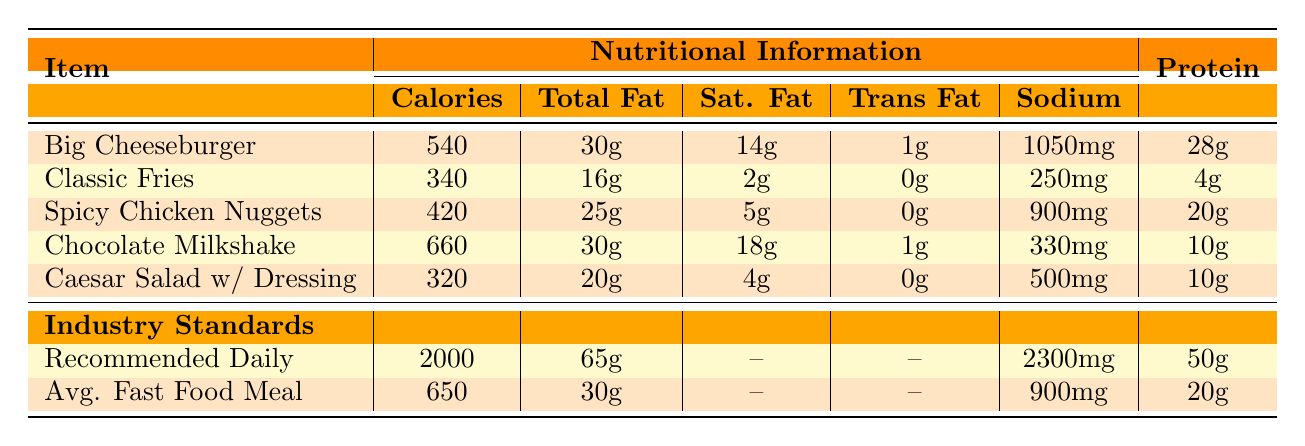What is the calorie content of the Chocolate Milkshake? The table shows that the Chocolate Milkshake has 660 calories listed under the Nutritional Information section.
Answer: 660 How much saturated fat is in the Big Cheeseburger? According to the table, the Big Cheeseburger contains 14g of saturated fat.
Answer: 14g Which menu item has the highest sodium content? By comparing the sodium values in the Nutritional Information, the Big Cheeseburger has the highest sodium content at 1050mg.
Answer: Big Cheeseburger What is the total amount of protein in the Classic Fries and Caesar Salad with Dressing combined? The protein in Classic Fries is 4g, and in the Caesar Salad with Dressing, it is 10g. Adding them together gives 4g + 10g = 14g.
Answer: 14g Is the sodium content in the Spicy Chicken Nuggets above the average fast food meal standard? The Spicy Chicken Nuggets have 900mg of sodium, which is the same as the average fast food meal standard (900mg). Therefore, it is not above the average.
Answer: No How much dietary fiber is in the Chocolate Milkshake compared to the average fast food meal? The Chocolate Milkshake contains 1g of dietary fiber, while the average fast food meal does not list dietary fiber. We can conclude that the Chocolate Milkshake has dietary fiber present, while the average does not specify it.
Answer: 1g (Chocolate Milkshake) What percentage of the Recommended Daily Intake of calories does the Big Cheeseburger represent? The Big Cheeseburger has 540 calories, and the Recommended Daily Intake is 2000 calories. To find the percentage: (540/2000) * 100 = 27%.
Answer: 27% Which fast food item has the least carbohydrates? The table lists the Caesar Salad with Dressing with the lowest total carbohydrates at 15g when compared to the other items.
Answer: Caesar Salad with Dressing What is the total fat content difference between the Classic Fries and the Spicy Chicken Nuggets? Classic Fries have 16g of total fat while Spicy Chicken Nuggets have 25g. The difference is 25g - 16g = 9g.
Answer: 9g Do any items exceed the Recommended Daily Limit of total fat? Both the Big Cheeseburger (30g) and the Chocolate Milkshake (30g) are equal to the average fast food meal (30g) but do not exceed the recommended daily limit of 65g. So none exceed this limit.
Answer: No 